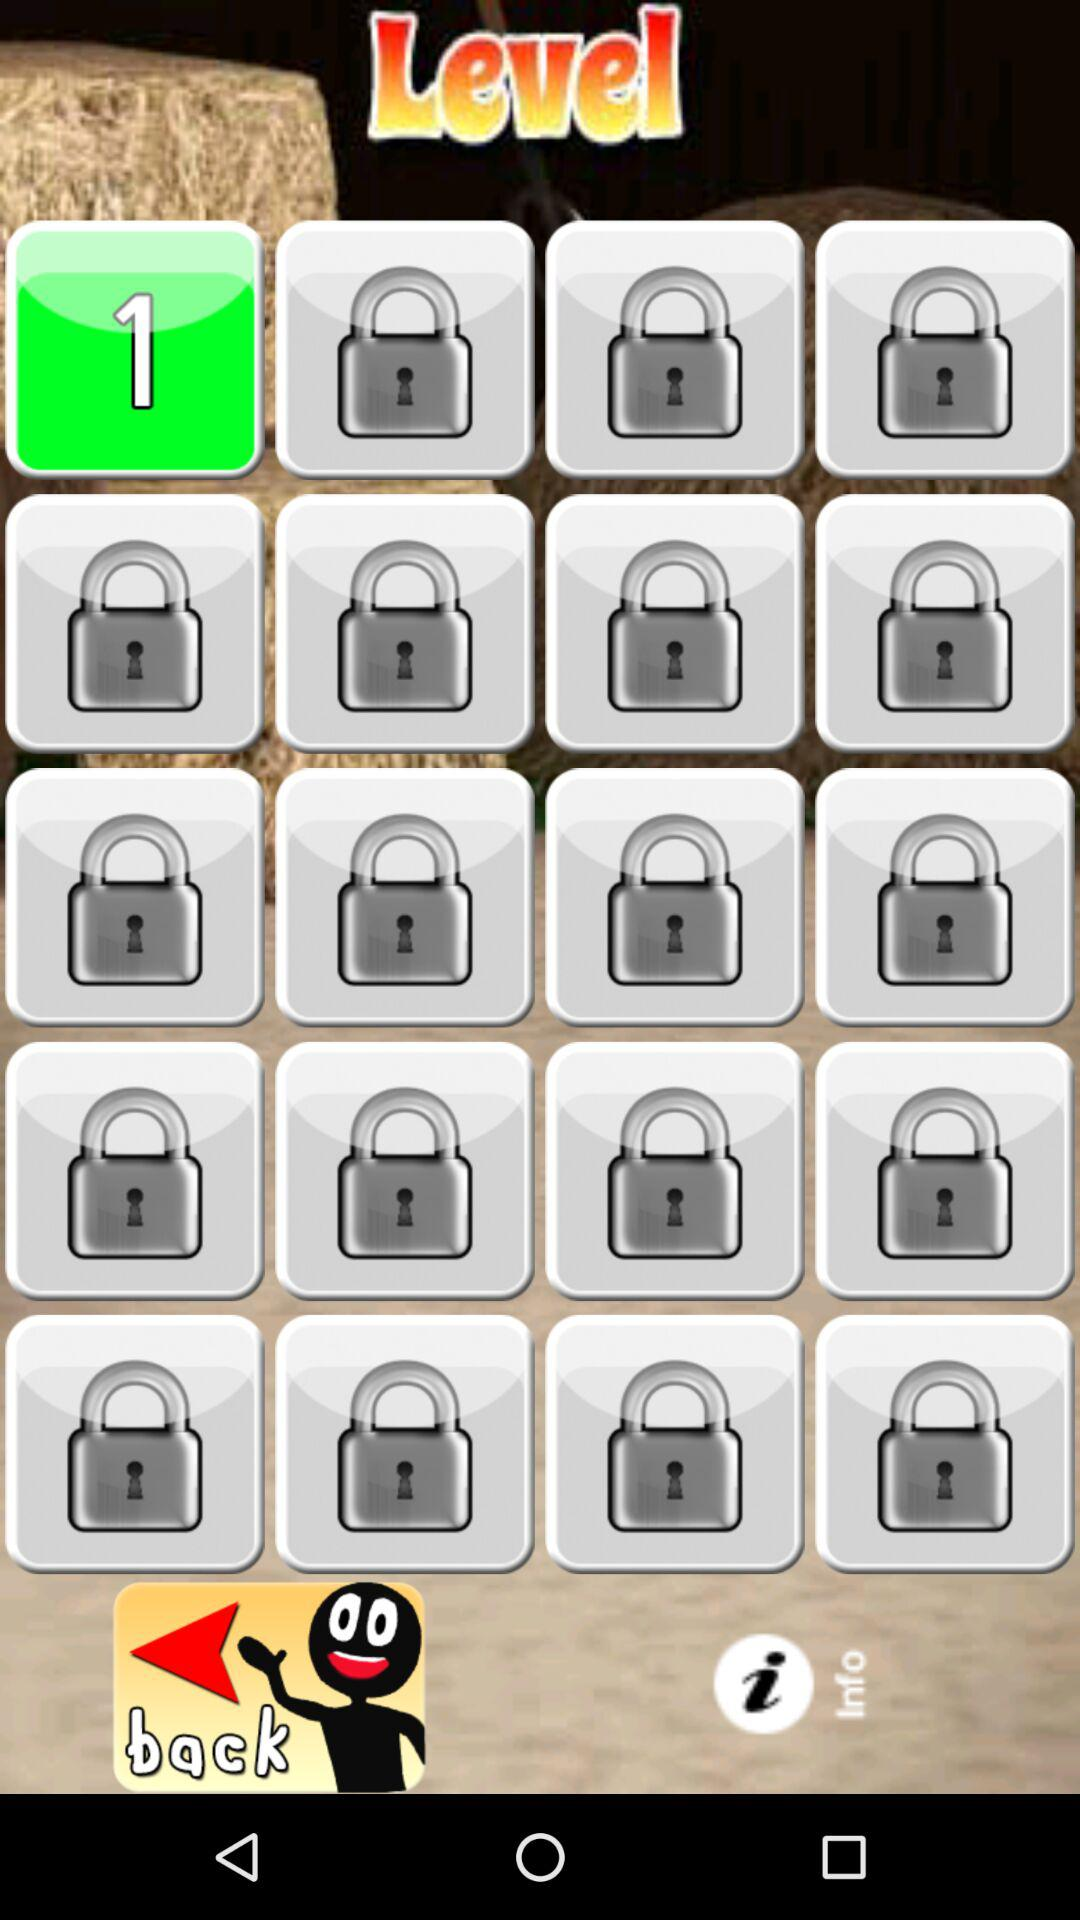Which level has been unlocked? The level unlocked is 1. 